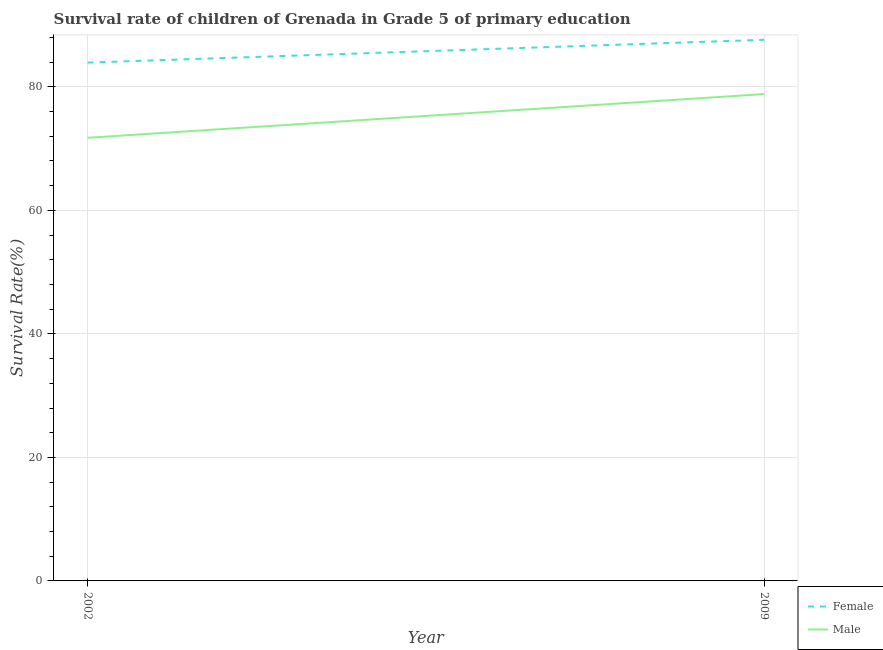How many different coloured lines are there?
Your answer should be very brief. 2. Does the line corresponding to survival rate of female students in primary education intersect with the line corresponding to survival rate of male students in primary education?
Your answer should be compact. No. Is the number of lines equal to the number of legend labels?
Your answer should be very brief. Yes. What is the survival rate of female students in primary education in 2002?
Your answer should be compact. 83.93. Across all years, what is the maximum survival rate of female students in primary education?
Make the answer very short. 87.63. Across all years, what is the minimum survival rate of female students in primary education?
Make the answer very short. 83.93. What is the total survival rate of male students in primary education in the graph?
Give a very brief answer. 150.59. What is the difference between the survival rate of male students in primary education in 2002 and that in 2009?
Provide a short and direct response. -7.08. What is the difference between the survival rate of female students in primary education in 2009 and the survival rate of male students in primary education in 2002?
Ensure brevity in your answer.  15.87. What is the average survival rate of female students in primary education per year?
Give a very brief answer. 85.78. In the year 2009, what is the difference between the survival rate of female students in primary education and survival rate of male students in primary education?
Your answer should be very brief. 8.79. What is the ratio of the survival rate of female students in primary education in 2002 to that in 2009?
Provide a short and direct response. 0.96. Is the survival rate of male students in primary education in 2002 less than that in 2009?
Give a very brief answer. Yes. In how many years, is the survival rate of female students in primary education greater than the average survival rate of female students in primary education taken over all years?
Ensure brevity in your answer.  1. Does the survival rate of male students in primary education monotonically increase over the years?
Your answer should be compact. Yes. Is the survival rate of female students in primary education strictly greater than the survival rate of male students in primary education over the years?
Make the answer very short. Yes. Is the survival rate of male students in primary education strictly less than the survival rate of female students in primary education over the years?
Provide a succinct answer. Yes. How many years are there in the graph?
Make the answer very short. 2. Does the graph contain any zero values?
Make the answer very short. No. How are the legend labels stacked?
Your answer should be compact. Vertical. What is the title of the graph?
Your response must be concise. Survival rate of children of Grenada in Grade 5 of primary education. What is the label or title of the X-axis?
Provide a succinct answer. Year. What is the label or title of the Y-axis?
Provide a short and direct response. Survival Rate(%). What is the Survival Rate(%) of Female in 2002?
Your response must be concise. 83.93. What is the Survival Rate(%) of Male in 2002?
Offer a very short reply. 71.76. What is the Survival Rate(%) of Female in 2009?
Ensure brevity in your answer.  87.63. What is the Survival Rate(%) of Male in 2009?
Your answer should be compact. 78.83. Across all years, what is the maximum Survival Rate(%) in Female?
Your response must be concise. 87.63. Across all years, what is the maximum Survival Rate(%) in Male?
Your answer should be very brief. 78.83. Across all years, what is the minimum Survival Rate(%) in Female?
Your response must be concise. 83.93. Across all years, what is the minimum Survival Rate(%) in Male?
Provide a succinct answer. 71.76. What is the total Survival Rate(%) in Female in the graph?
Make the answer very short. 171.56. What is the total Survival Rate(%) in Male in the graph?
Ensure brevity in your answer.  150.59. What is the difference between the Survival Rate(%) of Female in 2002 and that in 2009?
Your response must be concise. -3.69. What is the difference between the Survival Rate(%) in Male in 2002 and that in 2009?
Ensure brevity in your answer.  -7.08. What is the difference between the Survival Rate(%) of Female in 2002 and the Survival Rate(%) of Male in 2009?
Your response must be concise. 5.1. What is the average Survival Rate(%) in Female per year?
Your response must be concise. 85.78. What is the average Survival Rate(%) of Male per year?
Ensure brevity in your answer.  75.29. In the year 2002, what is the difference between the Survival Rate(%) in Female and Survival Rate(%) in Male?
Your answer should be compact. 12.18. In the year 2009, what is the difference between the Survival Rate(%) in Female and Survival Rate(%) in Male?
Offer a very short reply. 8.79. What is the ratio of the Survival Rate(%) of Female in 2002 to that in 2009?
Keep it short and to the point. 0.96. What is the ratio of the Survival Rate(%) in Male in 2002 to that in 2009?
Keep it short and to the point. 0.91. What is the difference between the highest and the second highest Survival Rate(%) in Female?
Offer a terse response. 3.69. What is the difference between the highest and the second highest Survival Rate(%) of Male?
Your answer should be very brief. 7.08. What is the difference between the highest and the lowest Survival Rate(%) of Female?
Offer a terse response. 3.69. What is the difference between the highest and the lowest Survival Rate(%) of Male?
Offer a very short reply. 7.08. 